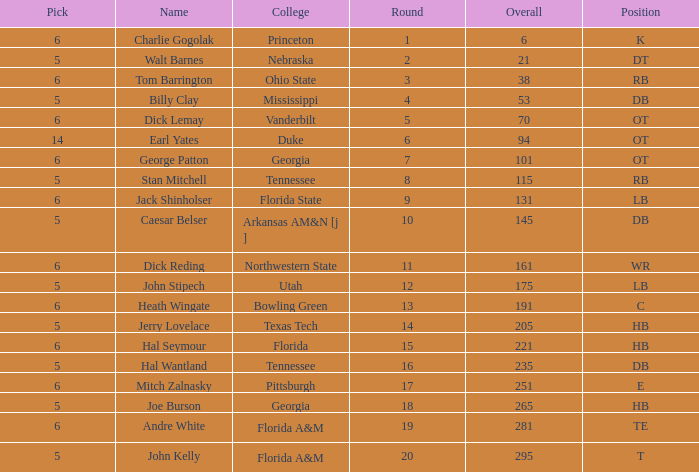What is Name, when Overall is less than 175, and when College is "Georgia"? George Patton. 